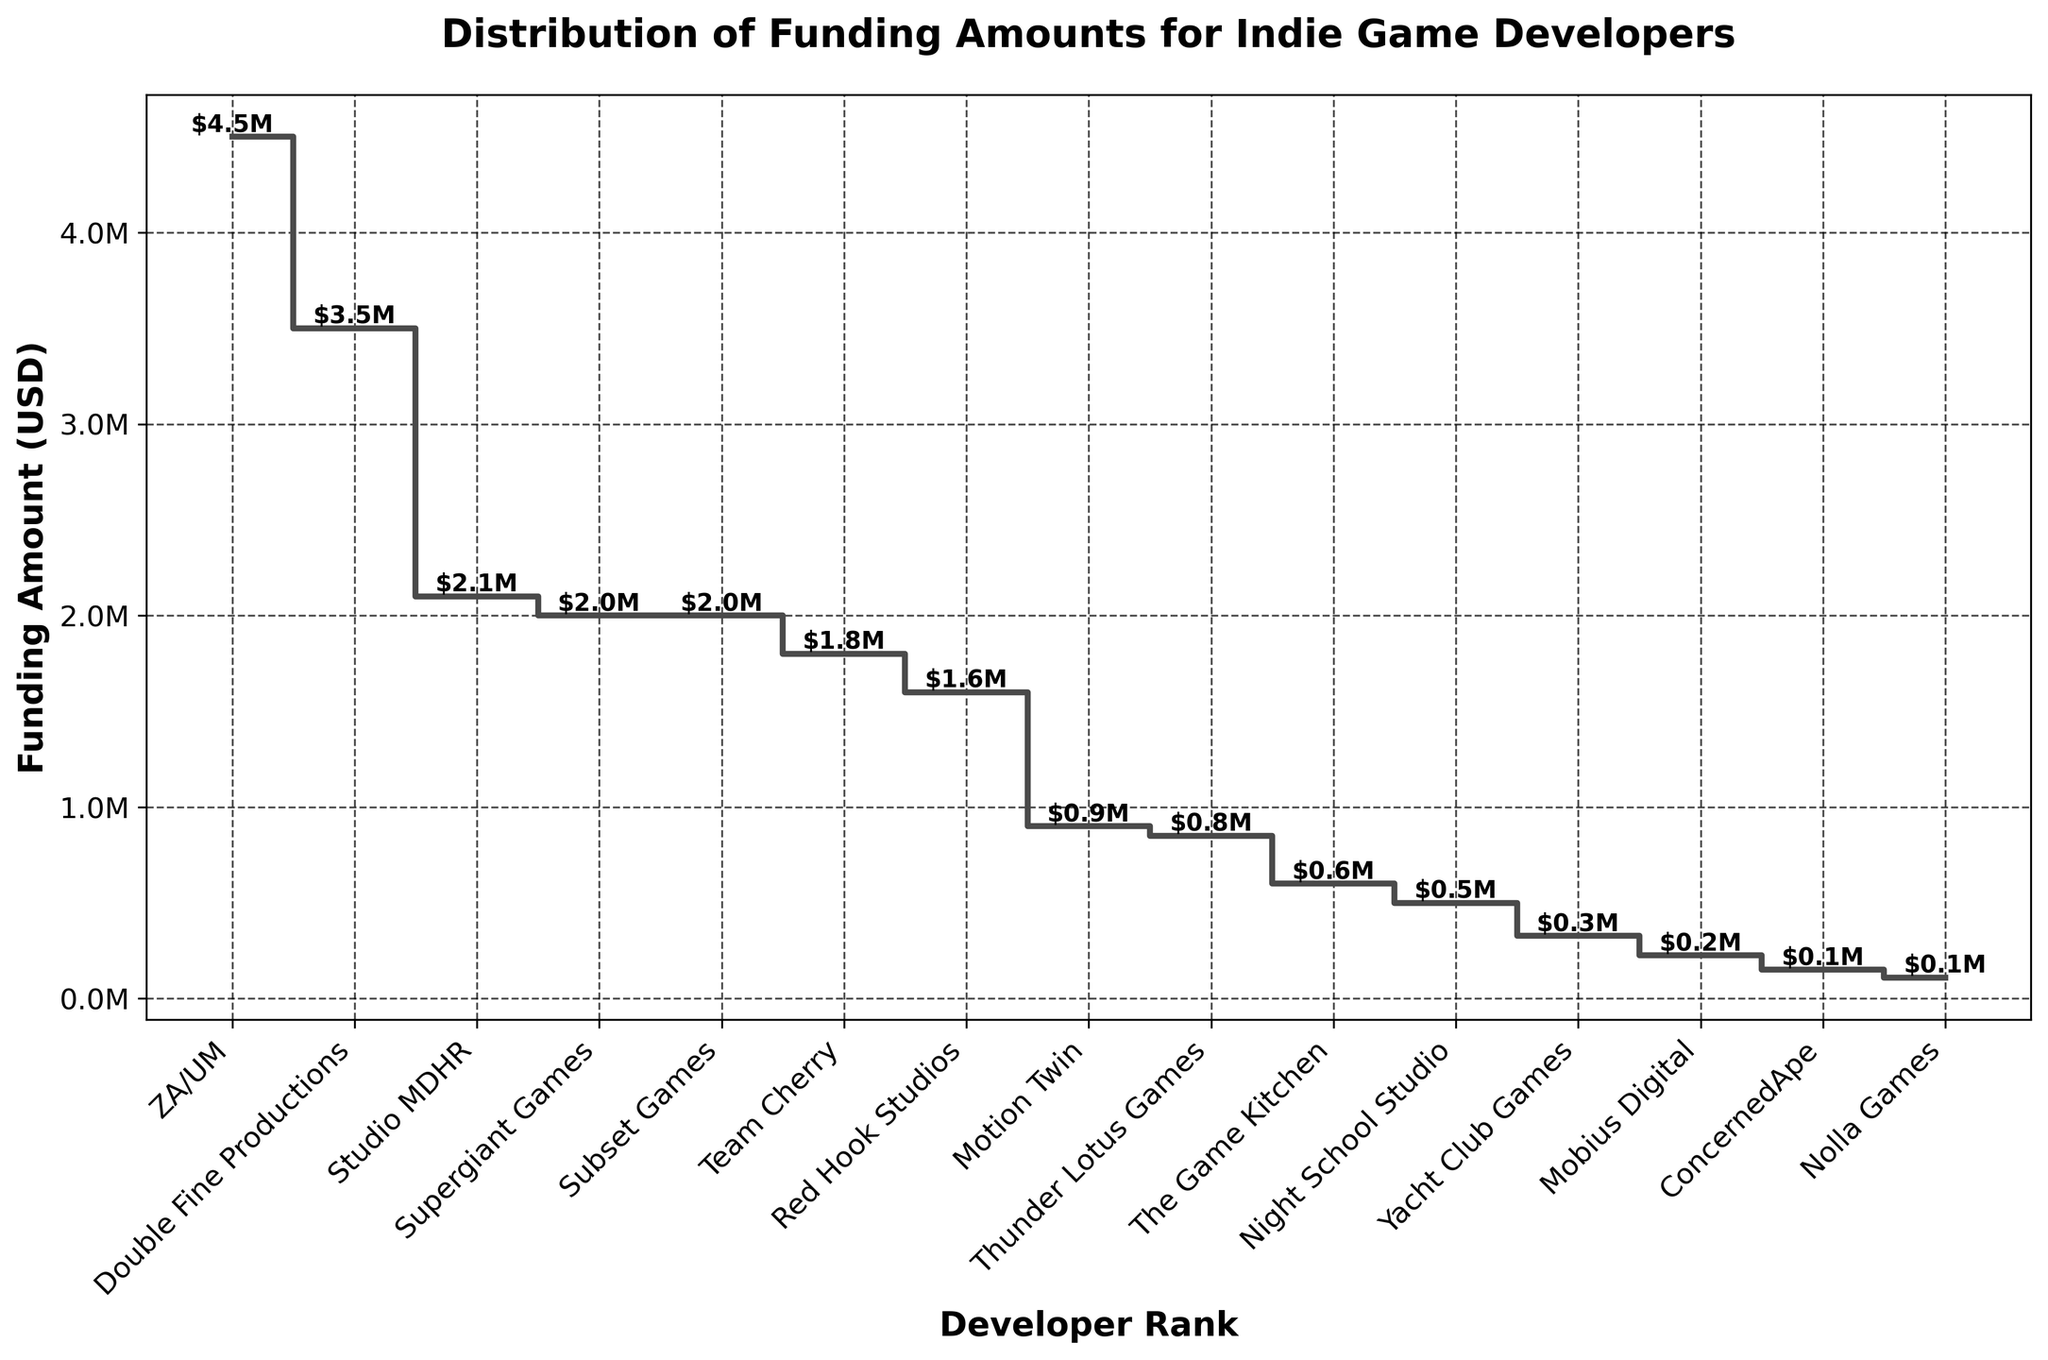What's the title of the plot? The title of the plot is prominently displayed at the top.
Answer: Distribution of Funding Amounts for Indie Game Developers What's the maximum funding amount received by any developer? The highest point on the y-axis step shows the maximum value, which is for the first data point.
Answer: $4.5M Which developer received the third-highest funding? The third-highest point in the plot corresponds to the label on the x-axis for that point.
Answer: Double Fine Productions What is the total funding amount received by the top three developers? Sum the funding amounts of the top three developers shown at the highest three steps. $4.5M + $3.5M + $2.1M.
Answer: $10.1M How many developers received a funding amount of $2 million or more? Count the number of steps that reach $2 million or higher on the y-axis.
Answer: 4 developers How does the funding amount for Team Cherry compare to Yacht Club Games? Find the step locations for Team Cherry and Yacht Club Games and compare their heights.
Answer: Team Cherry received more funding What is the average funding amount received by all developers? Sum all funding amounts and divide by the number of developers (15). Total is $4.5M + $3.5M + ... + $110K = $17,970,000. Average is $17,970,000 / 15.
Answer: $1.2M What's the funding amount difference between the highest and lowest funded developers? Subtract the funding amount of the lowest funded developer from the highest funded developer. $4.5M - $110K.
Answer: $4.39M Is there a noticeable funding gap between any two developers on the plot? Identify if there are any significant vertical jumps between two adjacent steps.
Answer: Yes, large gap between Double Fine Productions ($3.5M) and Studio MDHR ($2.1M) Which developer is ranked tenth in terms of funding amount? The tenth step on the x-axis label corresponds to the developer at that rank.
Answer: Mobius Digital 